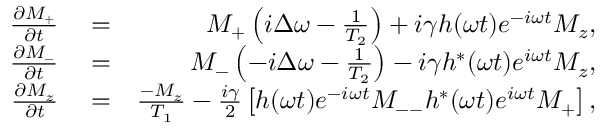Convert formula to latex. <formula><loc_0><loc_0><loc_500><loc_500>\begin{array} { r l r } { \frac { \partial M _ { + } } { \partial t } } & = } & { M _ { + } \left ( i \Delta \omega - \frac { 1 } { T _ { 2 } } \right ) + i \gamma h ( \omega t ) e ^ { - i \omega t } M _ { z } , } \\ { \frac { \partial M _ { - } } { \partial t } } & = } & { M _ { - } \left ( - i \Delta \omega - \frac { 1 } { T _ { 2 } } \right ) - i \gamma h ^ { * } ( \omega t ) e ^ { i \omega t } M _ { z } , } \\ { \frac { \partial M _ { z } } { \partial t } } & = } & { \frac { - M _ { z } } { T _ { 1 } } - \frac { i \gamma } { 2 } \left [ h ( \omega t ) e ^ { - i \omega t } M _ { - - } h ^ { * } ( \omega t ) e ^ { i \omega t } M _ { + } \right ] , } \end{array}</formula> 